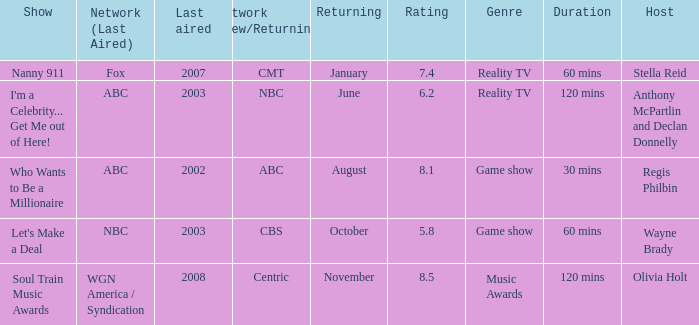When did soul train music awards return? November. 